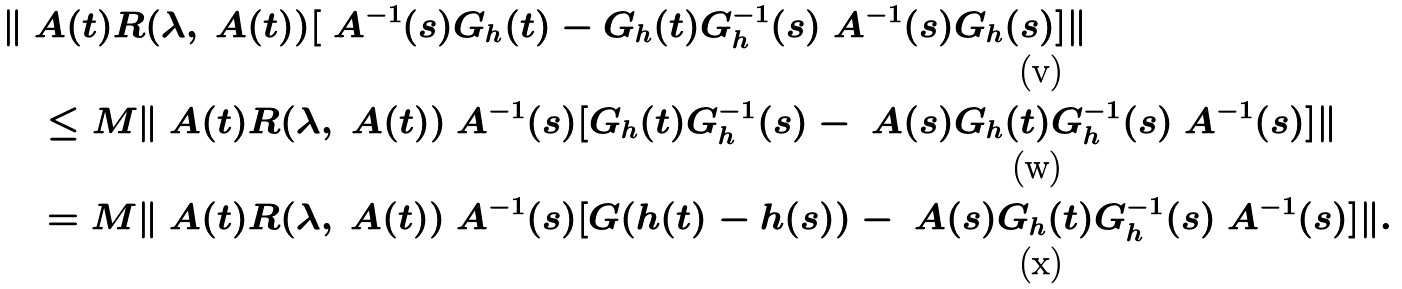Convert formula to latex. <formula><loc_0><loc_0><loc_500><loc_500>\ & \| \ A ( t ) R ( \lambda , \ A ( t ) ) [ \ A ^ { - 1 } ( s ) G _ { h } ( t ) - G _ { h } ( t ) G _ { h } ^ { - 1 } ( s ) \ A ^ { - 1 } ( s ) G _ { h } ( s ) ] \| \\ & \quad \leq M \| \ A ( t ) R ( \lambda , \ A ( t ) ) \ A ^ { - 1 } ( s ) [ G _ { h } ( t ) G _ { h } ^ { - 1 } ( s ) - \ A ( s ) G _ { h } ( t ) G _ { h } ^ { - 1 } ( s ) \ A ^ { - 1 } ( s ) ] \| \\ & \quad = M \| \ A ( t ) R ( \lambda , \ A ( t ) ) \ A ^ { - 1 } ( s ) [ G ( h ( t ) - h ( s ) ) - \ A ( s ) G _ { h } ( t ) G _ { h } ^ { - 1 } ( s ) \ A ^ { - 1 } ( s ) ] \| .</formula> 